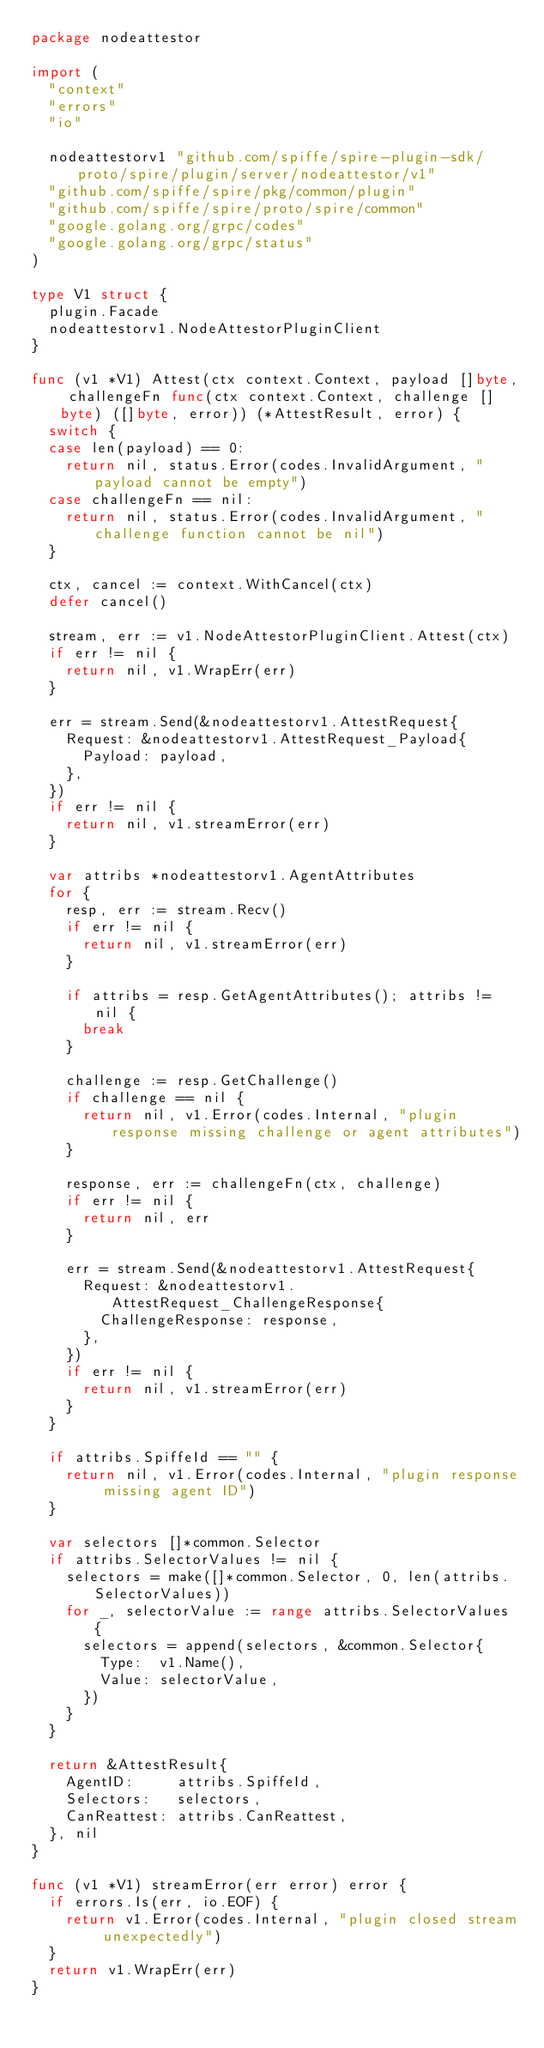Convert code to text. <code><loc_0><loc_0><loc_500><loc_500><_Go_>package nodeattestor

import (
	"context"
	"errors"
	"io"

	nodeattestorv1 "github.com/spiffe/spire-plugin-sdk/proto/spire/plugin/server/nodeattestor/v1"
	"github.com/spiffe/spire/pkg/common/plugin"
	"github.com/spiffe/spire/proto/spire/common"
	"google.golang.org/grpc/codes"
	"google.golang.org/grpc/status"
)

type V1 struct {
	plugin.Facade
	nodeattestorv1.NodeAttestorPluginClient
}

func (v1 *V1) Attest(ctx context.Context, payload []byte, challengeFn func(ctx context.Context, challenge []byte) ([]byte, error)) (*AttestResult, error) {
	switch {
	case len(payload) == 0:
		return nil, status.Error(codes.InvalidArgument, "payload cannot be empty")
	case challengeFn == nil:
		return nil, status.Error(codes.InvalidArgument, "challenge function cannot be nil")
	}

	ctx, cancel := context.WithCancel(ctx)
	defer cancel()

	stream, err := v1.NodeAttestorPluginClient.Attest(ctx)
	if err != nil {
		return nil, v1.WrapErr(err)
	}

	err = stream.Send(&nodeattestorv1.AttestRequest{
		Request: &nodeattestorv1.AttestRequest_Payload{
			Payload: payload,
		},
	})
	if err != nil {
		return nil, v1.streamError(err)
	}

	var attribs *nodeattestorv1.AgentAttributes
	for {
		resp, err := stream.Recv()
		if err != nil {
			return nil, v1.streamError(err)
		}

		if attribs = resp.GetAgentAttributes(); attribs != nil {
			break
		}

		challenge := resp.GetChallenge()
		if challenge == nil {
			return nil, v1.Error(codes.Internal, "plugin response missing challenge or agent attributes")
		}

		response, err := challengeFn(ctx, challenge)
		if err != nil {
			return nil, err
		}

		err = stream.Send(&nodeattestorv1.AttestRequest{
			Request: &nodeattestorv1.AttestRequest_ChallengeResponse{
				ChallengeResponse: response,
			},
		})
		if err != nil {
			return nil, v1.streamError(err)
		}
	}

	if attribs.SpiffeId == "" {
		return nil, v1.Error(codes.Internal, "plugin response missing agent ID")
	}

	var selectors []*common.Selector
	if attribs.SelectorValues != nil {
		selectors = make([]*common.Selector, 0, len(attribs.SelectorValues))
		for _, selectorValue := range attribs.SelectorValues {
			selectors = append(selectors, &common.Selector{
				Type:  v1.Name(),
				Value: selectorValue,
			})
		}
	}

	return &AttestResult{
		AgentID:     attribs.SpiffeId,
		Selectors:   selectors,
		CanReattest: attribs.CanReattest,
	}, nil
}

func (v1 *V1) streamError(err error) error {
	if errors.Is(err, io.EOF) {
		return v1.Error(codes.Internal, "plugin closed stream unexpectedly")
	}
	return v1.WrapErr(err)
}
</code> 